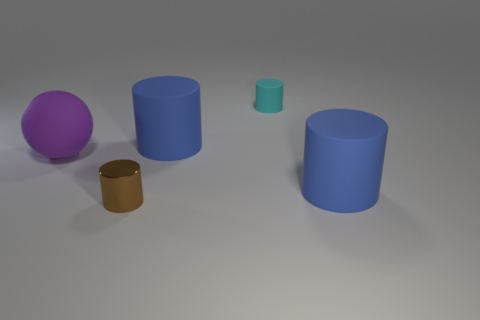What shape is the matte object that is both on the left side of the small cyan cylinder and right of the big sphere?
Make the answer very short. Cylinder. Is the number of tiny things that are in front of the tiny brown metal cylinder the same as the number of tiny cylinders in front of the large purple matte sphere?
Keep it short and to the point. No. Do the tiny thing that is on the right side of the brown metallic object and the purple object have the same shape?
Give a very brief answer. No. What number of yellow things are either big rubber objects or small rubber cylinders?
Give a very brief answer. 0. There is a small brown object that is the same shape as the cyan thing; what material is it?
Ensure brevity in your answer.  Metal. The blue object to the right of the small cyan cylinder has what shape?
Your response must be concise. Cylinder. Is there a small cylinder that has the same material as the purple sphere?
Offer a terse response. Yes. Does the cyan rubber cylinder have the same size as the brown object?
Offer a very short reply. Yes. What number of blocks are big blue things or small metallic objects?
Give a very brief answer. 0. How many other purple things have the same shape as the purple matte thing?
Ensure brevity in your answer.  0. 